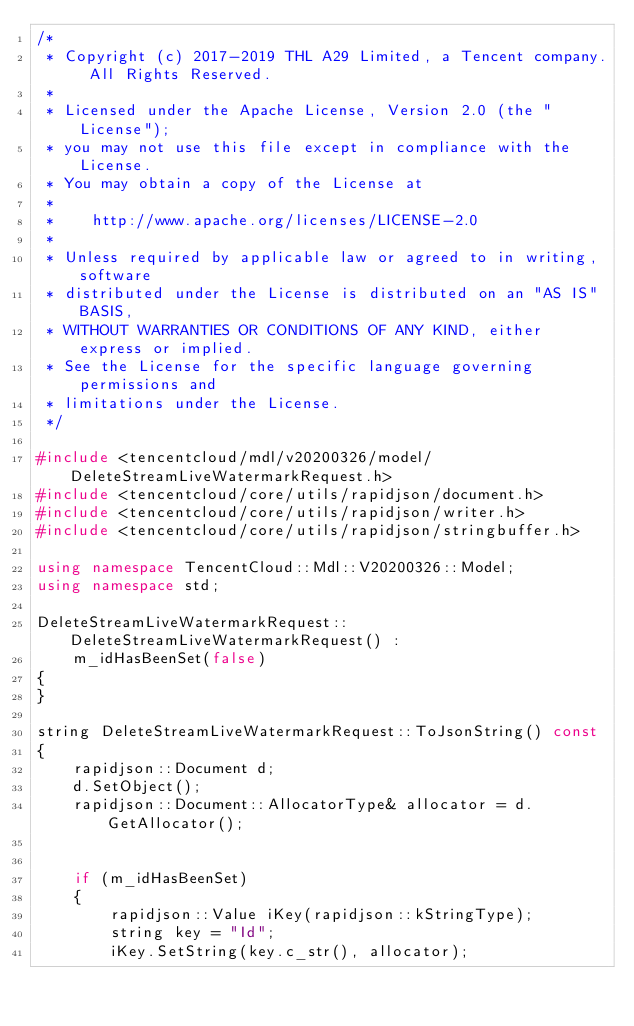Convert code to text. <code><loc_0><loc_0><loc_500><loc_500><_C++_>/*
 * Copyright (c) 2017-2019 THL A29 Limited, a Tencent company. All Rights Reserved.
 *
 * Licensed under the Apache License, Version 2.0 (the "License");
 * you may not use this file except in compliance with the License.
 * You may obtain a copy of the License at
 *
 *    http://www.apache.org/licenses/LICENSE-2.0
 *
 * Unless required by applicable law or agreed to in writing, software
 * distributed under the License is distributed on an "AS IS" BASIS,
 * WITHOUT WARRANTIES OR CONDITIONS OF ANY KIND, either express or implied.
 * See the License for the specific language governing permissions and
 * limitations under the License.
 */

#include <tencentcloud/mdl/v20200326/model/DeleteStreamLiveWatermarkRequest.h>
#include <tencentcloud/core/utils/rapidjson/document.h>
#include <tencentcloud/core/utils/rapidjson/writer.h>
#include <tencentcloud/core/utils/rapidjson/stringbuffer.h>

using namespace TencentCloud::Mdl::V20200326::Model;
using namespace std;

DeleteStreamLiveWatermarkRequest::DeleteStreamLiveWatermarkRequest() :
    m_idHasBeenSet(false)
{
}

string DeleteStreamLiveWatermarkRequest::ToJsonString() const
{
    rapidjson::Document d;
    d.SetObject();
    rapidjson::Document::AllocatorType& allocator = d.GetAllocator();


    if (m_idHasBeenSet)
    {
        rapidjson::Value iKey(rapidjson::kStringType);
        string key = "Id";
        iKey.SetString(key.c_str(), allocator);</code> 